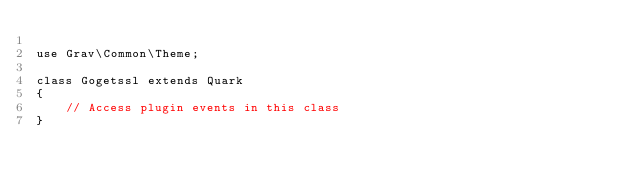<code> <loc_0><loc_0><loc_500><loc_500><_PHP_>
use Grav\Common\Theme;

class Gogetssl extends Quark
{
    // Access plugin events in this class
}
</code> 